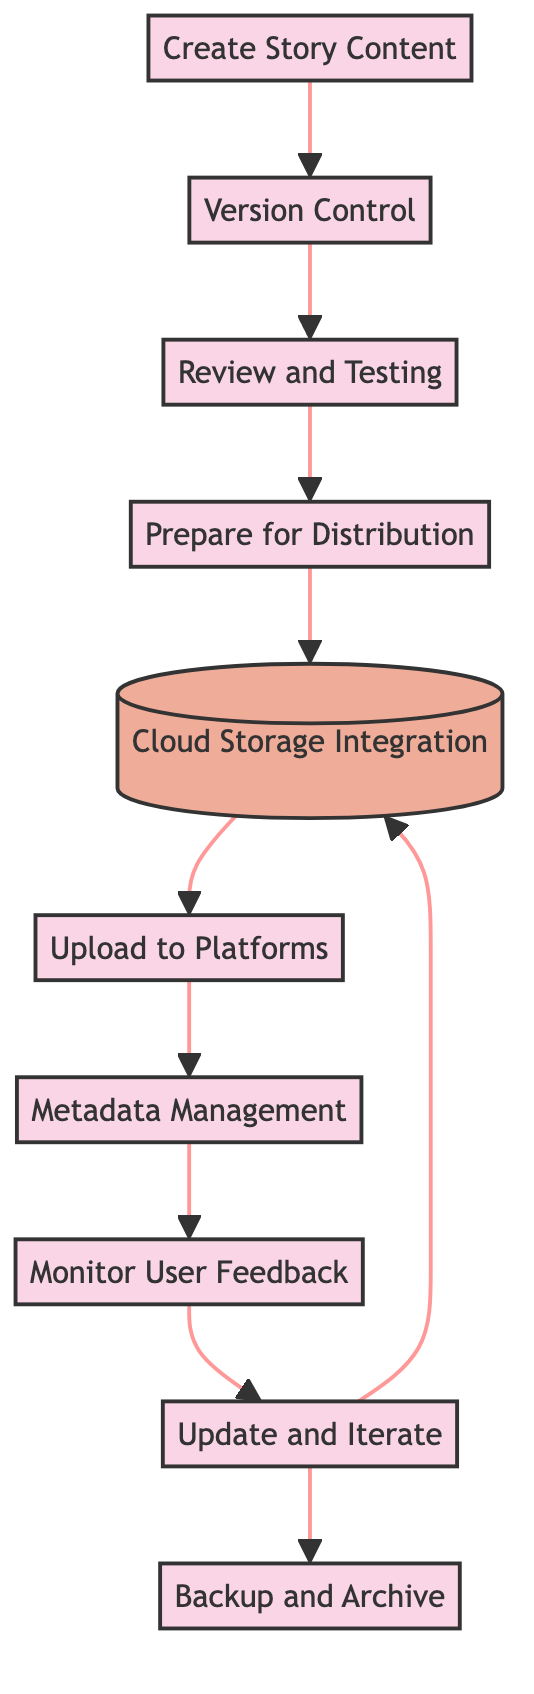What is the first step in the workflow? The first step is indicated by the top node in the flow chart, which is "Create Story Content." This node has no incoming edges, showing that it's the starting point of the process.
Answer: Create Story Content How many processes are in the workflow? To determine the number of processes, we count all the nodes labeled as "process" in the diagram. There are eight nodes that represent processes: Create Story Content, Version Control, Review and Testing, Prepare for Distribution, Upload to Platforms, Metadata Management, Monitor User Feedback, and Update and Iterate.
Answer: Eight What is the last process before backing up and archiving? The last process before backup and archiving is "Update and Iterate," which points to the "Backup and Archive" node. This indicates that one should update and iterate based on feedback before backing up the work.
Answer: Update and Iterate Which process connects to Cloud Storage Integration? "Prepare for Distribution" directly connects to "Cloud Storage Integration," as indicated by the flow of the chart. This shows that the work should be formatted for different platforms before integration with cloud storage.
Answer: Prepare for Distribution What type of element is "Cloud Storage Integration"? In the flow chart, "Cloud Storage Integration" is depicted as a storage element, which is visually distinct from the process elements. It is represented in a different color to indicate its role as a storage solution rather than a process in the workflow.
Answer: Storage How many times can one update and iterate based on user feedback before archiving? The workflow allows for one iteration of "Update and Iterate" before leading to "Backup and Archive." There are no additional paths leading from "Update and Iterate" to any other processes before reaching the backup step, meaning the workflow indicates a single loop for updates.
Answer: One What connects "Monitor User Feedback" and "Update and Iterate"? The edge labeled with a direct connection indicates that "Monitor User Feedback" leads to "Update and Iterate." This shows that after collecting user feedback, the author can then make adjustments and updates.
Answer: One direct connection What is required before uploading to platforms? Before uploading to platforms, "Prepare for Distribution" must be completed, which forms a necessary step in the workflow. This indicates that the story needs to be properly formatted for the various platforms before being distributed.
Answer: Prepare for Distribution 